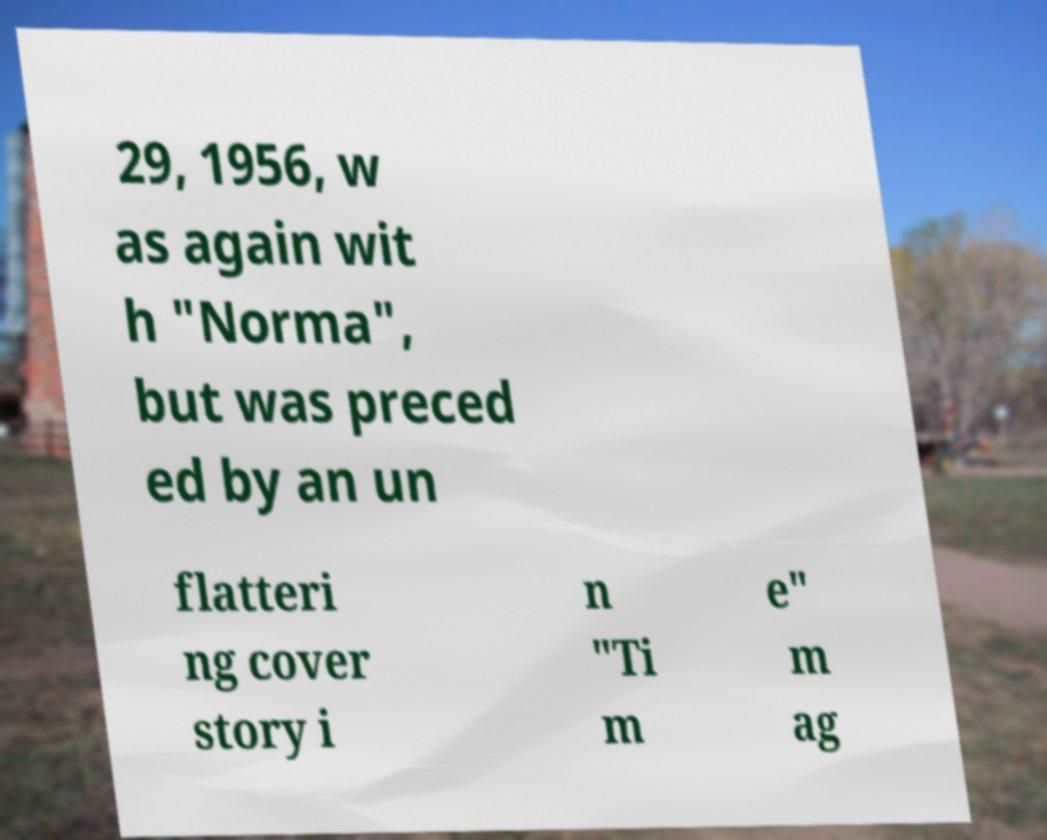For documentation purposes, I need the text within this image transcribed. Could you provide that? 29, 1956, w as again wit h "Norma", but was preced ed by an un flatteri ng cover story i n "Ti m e" m ag 